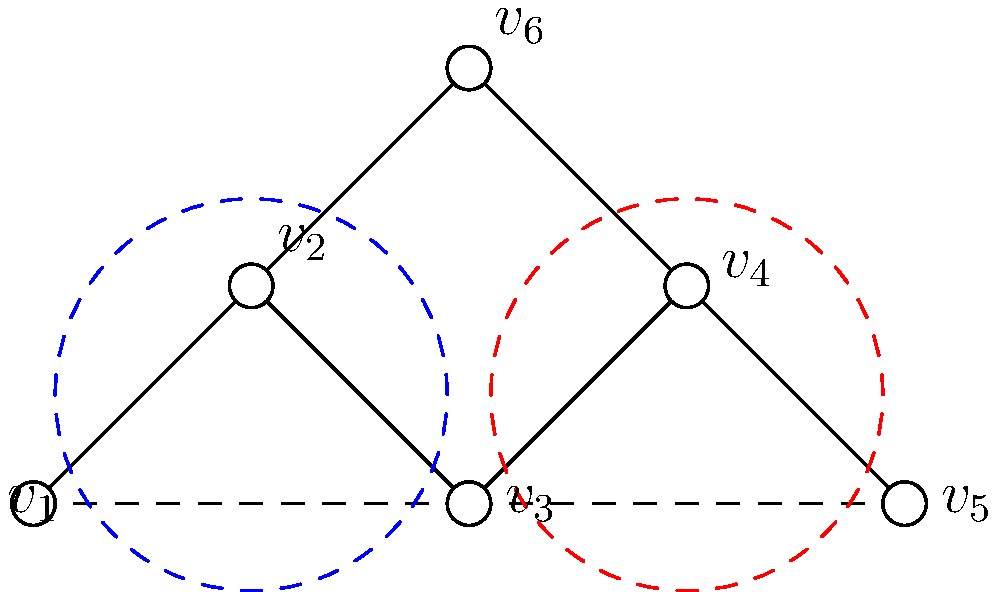Given the brain network represented by the graph, where vertices represent brain regions and edges represent functional connections, which community detection algorithm would be most suitable for identifying the unique functional modules in this patient's brain, and why? To answer this question, we need to consider the characteristics of the given brain network and the properties of various community detection algorithms:

1. Network structure: The graph shows two distinct communities (blue and red dashed circles) with some inter-community connections.

2. Overlapping communities: There's a potential overlap between communities, as vertex $v_3$ seems to be part of both communities.

3. Weighted vs. unweighted: The graph doesn't show edge weights, suggesting an unweighted network.

4. Network size: This is a small network with only 6 vertices, which may not be representative of a full brain network but serves as a simplified model.

Given these characteristics, we can consider the following algorithms:

a) Louvain algorithm: Good for large networks, but may not capture overlapping communities well.

b) Girvan-Newman algorithm: Suitable for smaller networks but doesn't allow for overlapping communities.

c) Clique Percolation Method (CPM): Allows for overlapping communities but may not work well with sparse networks.

d) OSLOM (Order Statistics Local Optimization Method): Capable of detecting overlapping communities and works well with both weighted and unweighted networks.

Considering the potential for overlapping communities and the unweighted nature of the network, the OSLOM algorithm would be most suitable for this patient's unique brain structure. It can detect statistically significant clusters and allows for overlapping communities, which is crucial for understanding the complex functional modules in this patient's brain.
Answer: OSLOM (Order Statistics Local Optimization Method) 